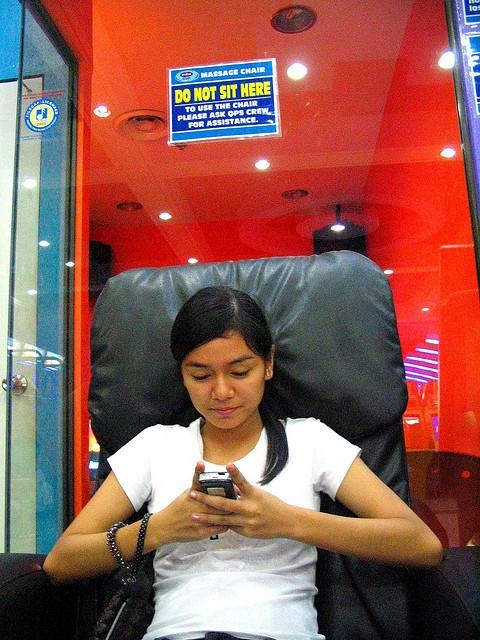What service is this lady receiving? massage 